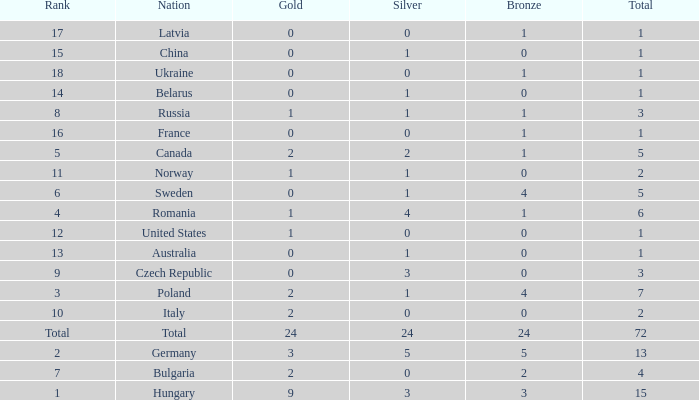What average total has 0 as the gold, with 6 as the rank? 5.0. Parse the table in full. {'header': ['Rank', 'Nation', 'Gold', 'Silver', 'Bronze', 'Total'], 'rows': [['17', 'Latvia', '0', '0', '1', '1'], ['15', 'China', '0', '1', '0', '1'], ['18', 'Ukraine', '0', '0', '1', '1'], ['14', 'Belarus', '0', '1', '0', '1'], ['8', 'Russia', '1', '1', '1', '3'], ['16', 'France', '0', '0', '1', '1'], ['5', 'Canada', '2', '2', '1', '5'], ['11', 'Norway', '1', '1', '0', '2'], ['6', 'Sweden', '0', '1', '4', '5'], ['4', 'Romania', '1', '4', '1', '6'], ['12', 'United States', '1', '0', '0', '1'], ['13', 'Australia', '0', '1', '0', '1'], ['9', 'Czech Republic', '0', '3', '0', '3'], ['3', 'Poland', '2', '1', '4', '7'], ['10', 'Italy', '2', '0', '0', '2'], ['Total', 'Total', '24', '24', '24', '72'], ['2', 'Germany', '3', '5', '5', '13'], ['7', 'Bulgaria', '2', '0', '2', '4'], ['1', 'Hungary', '9', '3', '3', '15']]} 